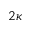Convert formula to latex. <formula><loc_0><loc_0><loc_500><loc_500>2 \kappa</formula> 